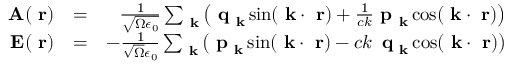<formula> <loc_0><loc_0><loc_500><loc_500>\begin{array} { r l r } { A ( r ) } & { = } & { \frac { 1 } { \sqrt { \Omega \epsilon _ { 0 } } } \sum _ { k } \left ( q _ { k } \sin ( k \cdot r ) + \frac { 1 } { c k } p _ { k } \cos ( k \cdot r ) \right ) } \\ { E ( r ) } & { = } & { - \frac { 1 } { \sqrt { \Omega } \epsilon _ { 0 } } \sum _ { k } \left ( p _ { k } \sin ( k \cdot r ) - c k \, q _ { k } \cos ( k \cdot r ) \right ) } \end{array}</formula> 